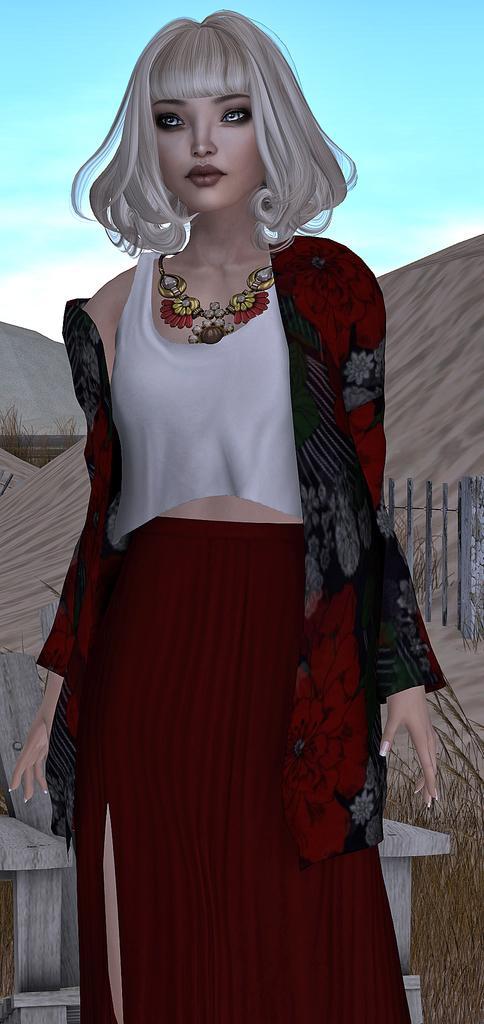Describe this image in one or two sentences. This is an animated picture, in this picture there is a woman standing and we can see grass, chair, fence and hills. In the background of the image we can see the sky. 